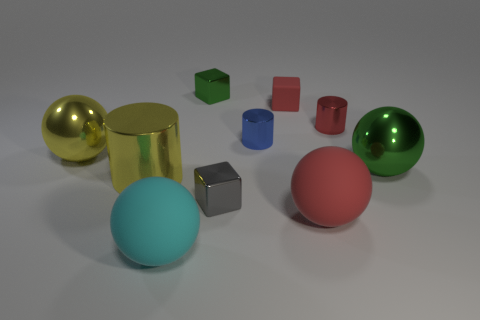What is the material of the cylinder that is the same color as the tiny matte thing?
Give a very brief answer. Metal. There is a green metal thing that is behind the big metallic object right of the red metallic cylinder; how many tiny blue cylinders are left of it?
Your response must be concise. 0. There is a cyan object; is its shape the same as the large rubber thing that is on the right side of the tiny gray cube?
Provide a succinct answer. Yes. Is the number of small brown objects greater than the number of big yellow metal cylinders?
Offer a very short reply. No. Is there any other thing that has the same size as the blue metallic object?
Provide a succinct answer. Yes. Is the shape of the large object that is left of the yellow cylinder the same as  the tiny rubber thing?
Your response must be concise. No. Is the number of balls in front of the large red ball greater than the number of tiny brown shiny things?
Provide a succinct answer. Yes. What color is the large metal ball right of the large rubber sphere that is on the right side of the big cyan matte ball?
Provide a short and direct response. Green. What number of rubber balls are there?
Your answer should be very brief. 2. What number of green objects are to the left of the big green sphere and on the right side of the small green shiny cube?
Offer a terse response. 0. 